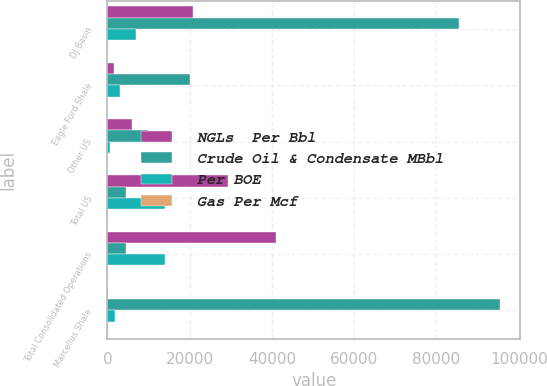Convert chart to OTSL. <chart><loc_0><loc_0><loc_500><loc_500><stacked_bar_chart><ecel><fcel>DJ Basin<fcel>Eagle Ford Shale<fcel>Other US<fcel>Total US<fcel>Total Consolidated Operations<fcel>Marcellus Shale<nl><fcel>NGLs  Per Bbl<fcel>20909<fcel>1656<fcel>6024<fcel>29262<fcel>40887<fcel>239<nl><fcel>Crude Oil & Condensate MBbl<fcel>85369<fcel>19969<fcel>9837<fcel>4549<fcel>4549<fcel>95564<nl><fcel>Per BOE<fcel>6910<fcel>3074<fcel>631<fcel>14095<fcel>14095<fcel>1812<nl><fcel>Gas Per Mcf<fcel>44.37<fcel>31.65<fcel>45.91<fcel>43.46<fcel>45<fcel>69.5<nl></chart> 